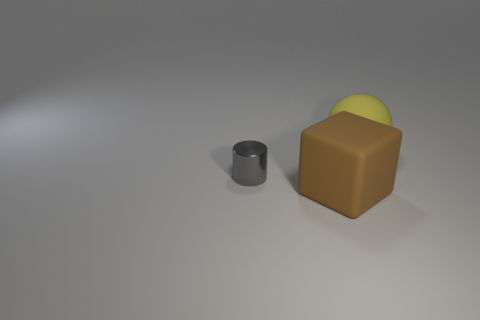How many things are either large yellow objects or objects in front of the large yellow sphere?
Your response must be concise. 3. There is a object that is right of the matte thing that is in front of the big yellow thing; what number of rubber things are to the left of it?
Provide a succinct answer. 1. Are there any shiny cylinders that are left of the thing that is on the left side of the large brown matte object?
Offer a terse response. No. How many tiny green shiny spheres are there?
Provide a succinct answer. 0. There is a thing that is behind the big block and on the right side of the gray object; what is its color?
Your response must be concise. Yellow. What number of brown matte things are the same size as the yellow thing?
Give a very brief answer. 1. What is the material of the cylinder?
Offer a terse response. Metal. There is a yellow thing; are there any brown things in front of it?
Ensure brevity in your answer.  Yes. How many objects have the same color as the matte cube?
Ensure brevity in your answer.  0. Is the number of balls that are in front of the large yellow rubber object less than the number of brown blocks that are in front of the brown rubber object?
Your answer should be very brief. No. 